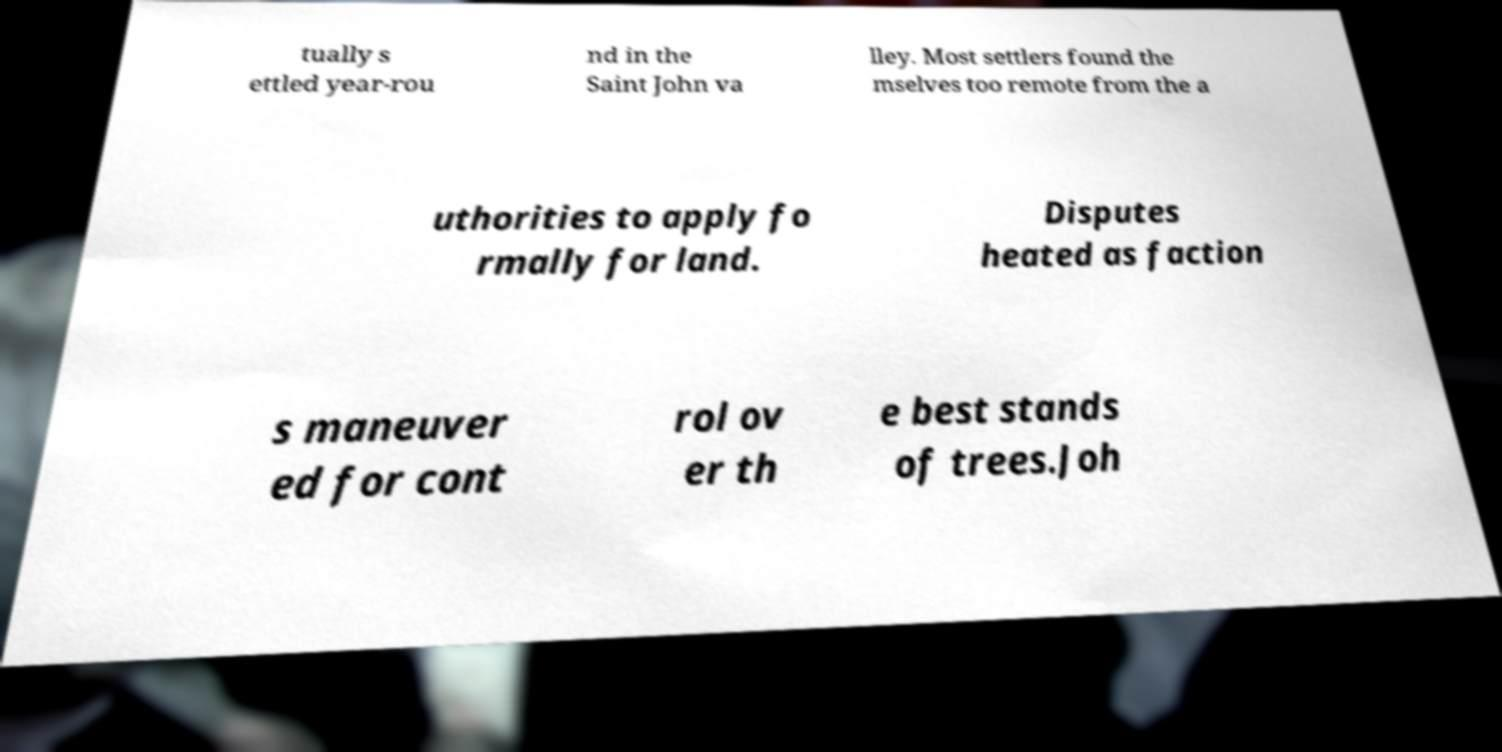Please identify and transcribe the text found in this image. tually s ettled year-rou nd in the Saint John va lley. Most settlers found the mselves too remote from the a uthorities to apply fo rmally for land. Disputes heated as faction s maneuver ed for cont rol ov er th e best stands of trees.Joh 